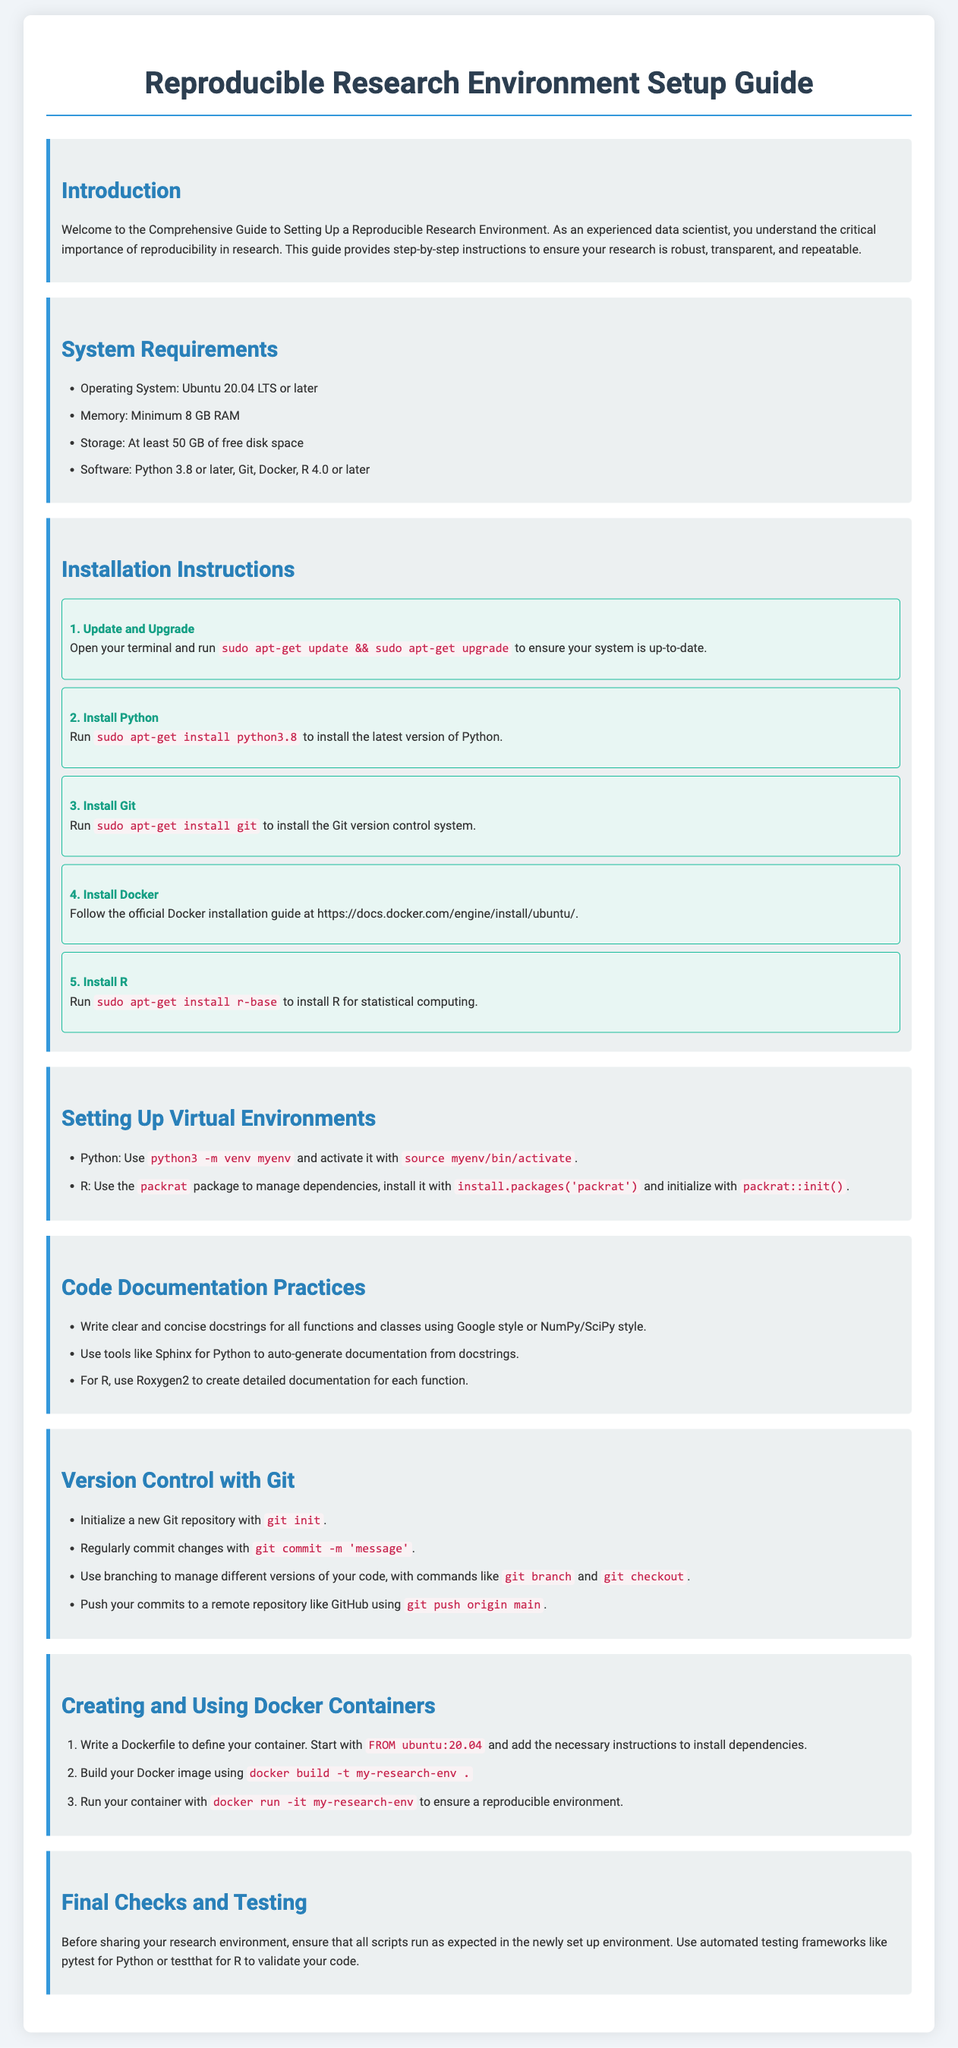What is the minimum memory requirement? The document specifies that the minimum memory requirement is 8 GB RAM.
Answer: 8 GB RAM What is the latest version of Python mentioned? The document states that Python version 3.8 or later is required.
Answer: 3.8 or later How many steps are in the installation instructions? The installation instructions contain a total of five steps.
Answer: Five What should be used to manage R dependencies? The document recommends using the packrat package for R dependency management.
Answer: packrat What is the command to initialize a new Git repository? The document provides the command for initializing a Git repository as git init.
Answer: git init How should you document Python functions according to the guide? The guide suggests writing clear and concise docstrings using Google style or NumPy/SciPy style.
Answer: Google style or NumPy/SciPy style What is the command to build a Docker image? The document states the command for building a Docker image is docker build -t my-research-env.
Answer: docker build -t my-research-env What testing framework is recommended for Python? According to the document, pytest is recommended for automated testing in Python.
Answer: pytest What is the primary theme of this guide? The primary theme of the guide is setting up a reproducible research environment.
Answer: reproducible research environment 